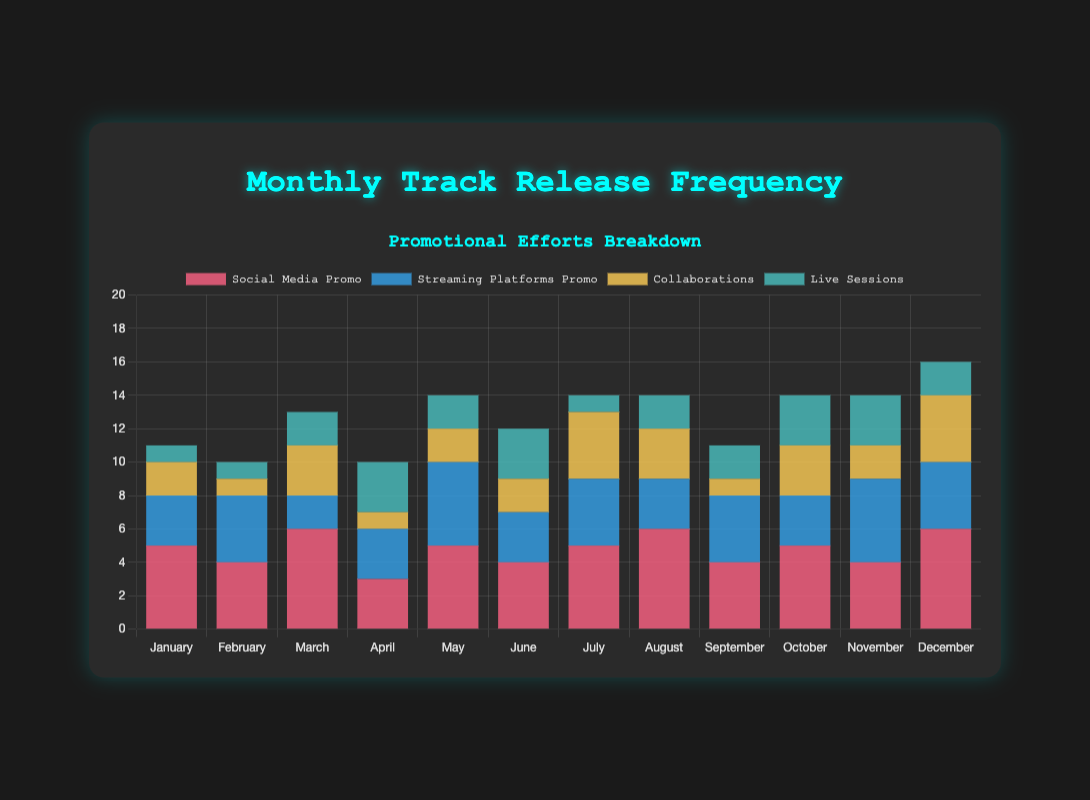Which month had the highest total track release frequency? By visually inspecting the stacked bar chart, we see that the month with the highest total track releases is the one with the tallest stacked bar. Here, December has the tallest stacked bar.
Answer: December How many total tracks were released in February and March combined? Sum the lengths of the stacked bars for February and March. February (4, 4, 1, 1) has a total of 10, and March (6, 2, 3, 2) has a total of 13. Adding these together, we get 10 + 13 = 23.
Answer: 23 Which promotional effort had the highest frequency in August? In August, social media promo has the largest portion of the stacked bar. This is the red section. So, social media promo had the highest frequency.
Answer: Social Media Promo Did June or July have more live sessions? Compare the height of the green sections representing live sessions. June's green section is taller (3) compared to July's green section (1). Thus, June had more live sessions.
Answer: June How did the number of collaborations in September compare to those in October? Visually inspect the yellow sections of the stacked bars for September and October. September has 1 collaboration, and October has 3 collaborations. October had more collaborations.
Answer: October Which month had the lowest streaming platforms promo effort? Look for the shortest blue sections in the stacked bars. April and March both have equal shortest blue sections with 2.
Answer: March, April What is the combined total number of tracks promoted via social media and live sessions in May? Sum the height of the red and green sections for May. Red is 5 and green is 2, so 5 + 2 = 7.
Answer: 7 On average, how many tracks were released each month using streaming platforms promo? Sum the streaming platforms promo numbers for all months and divide by 12. (3+4+2+3+5+3+4+3+4+3+5+4)/12 = 3.583.
Answer: 3.583 What's the difference in the number of live sessions between January and November? Subtract the number of live sessions in January (1) from November (3). 3 - 1 = 2.
Answer: 2 How many months had exactly 4 promotional efforts for streaming platforms? Count the number of months where the blue section is 4. These months are February, July, September, and December. Thus, there are 4 months.
Answer: 4 